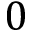<formula> <loc_0><loc_0><loc_500><loc_500>0</formula> 